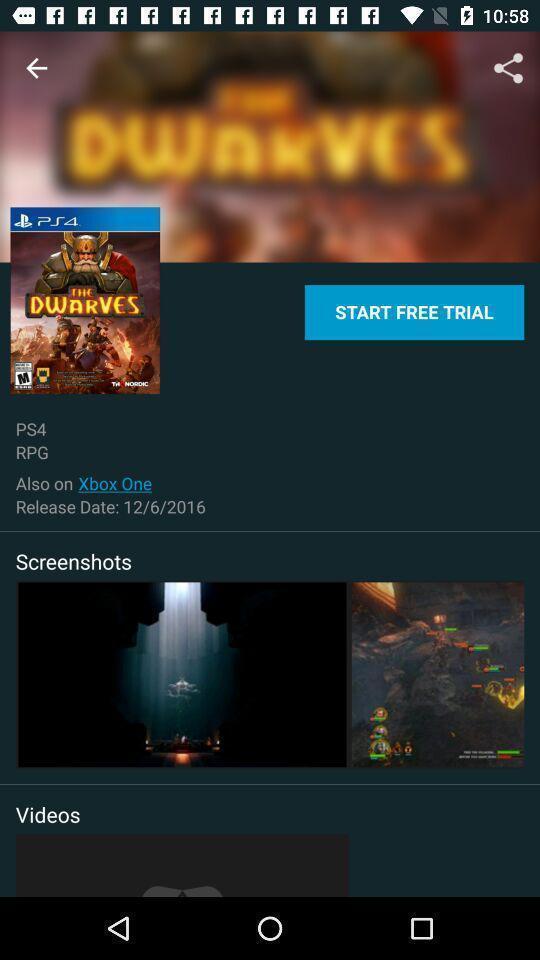Tell me about the visual elements in this screen capture. Video game of a movie app. 